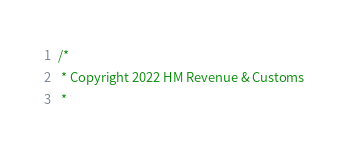<code> <loc_0><loc_0><loc_500><loc_500><_Scala_>/*
 * Copyright 2022 HM Revenue & Customs
 *</code> 